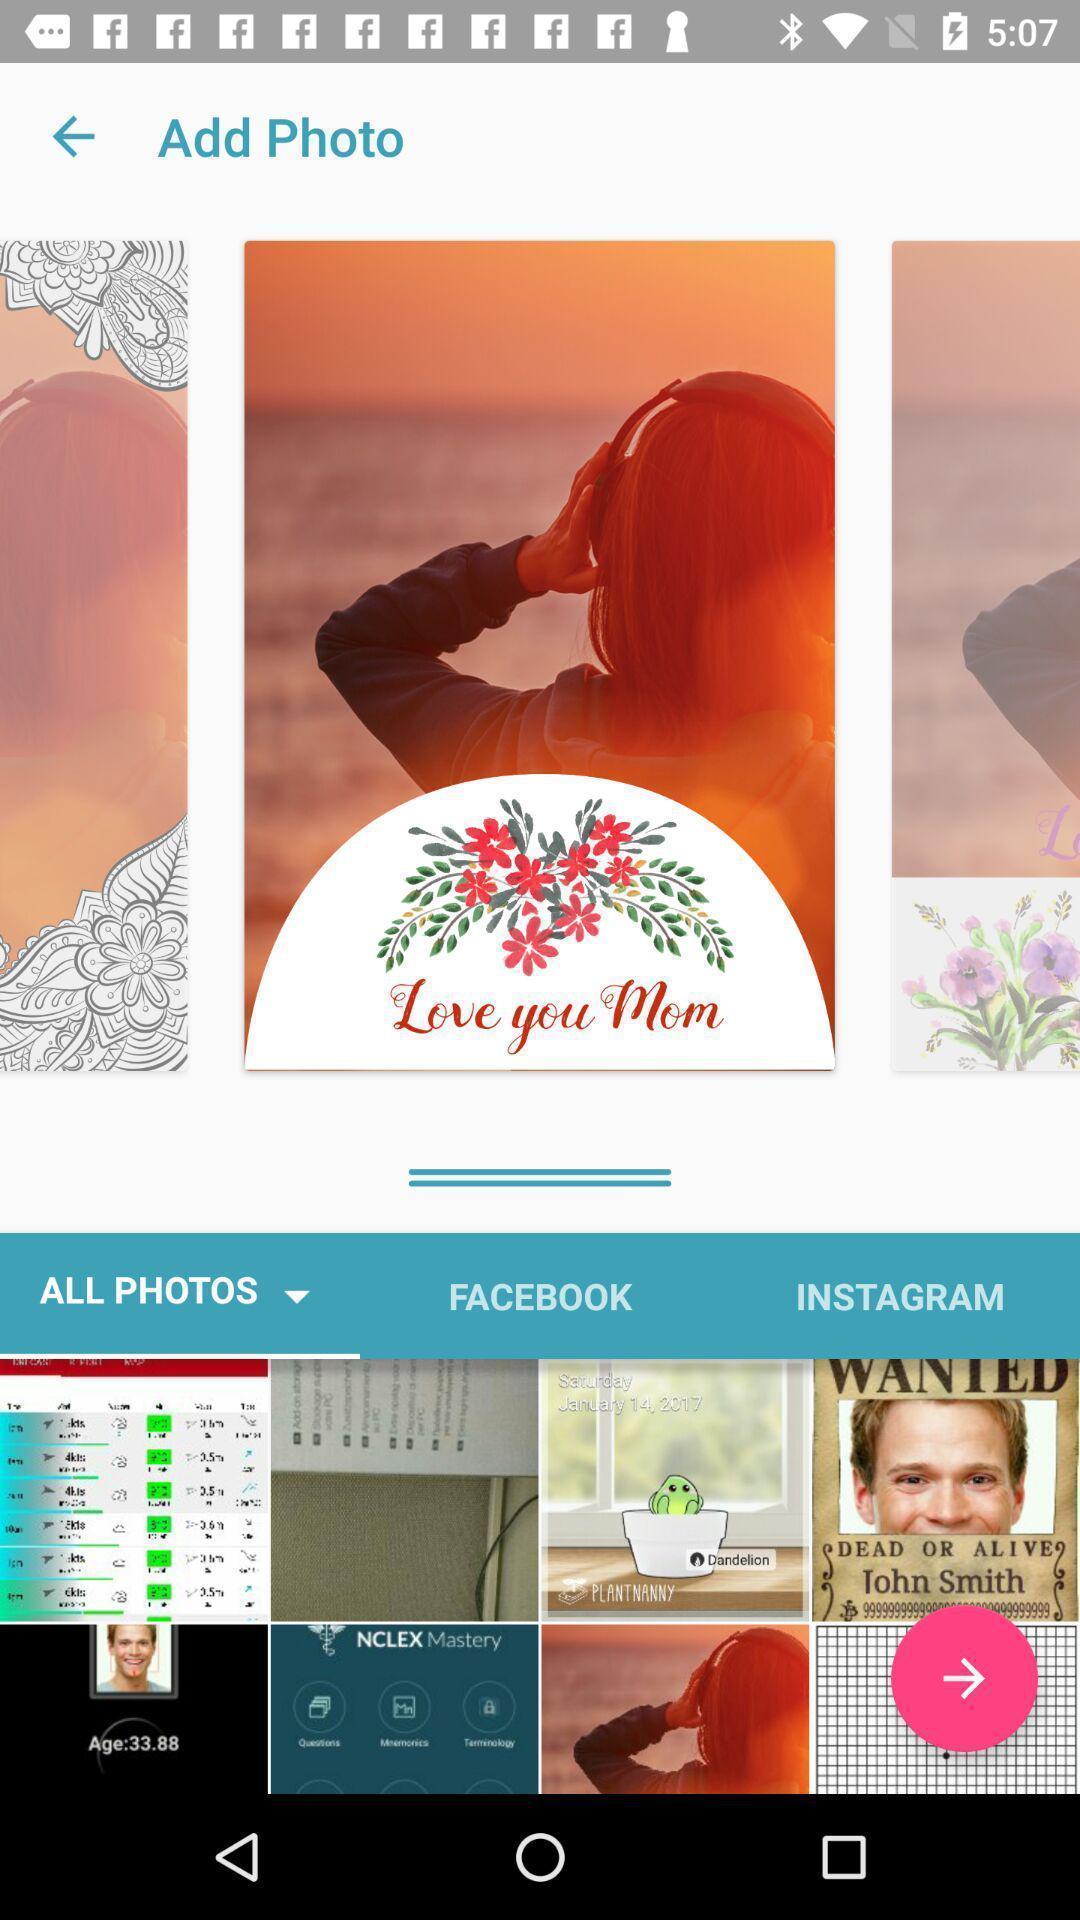Describe the visual elements of this screenshot. Page showing options to add photo in social networking apps. 